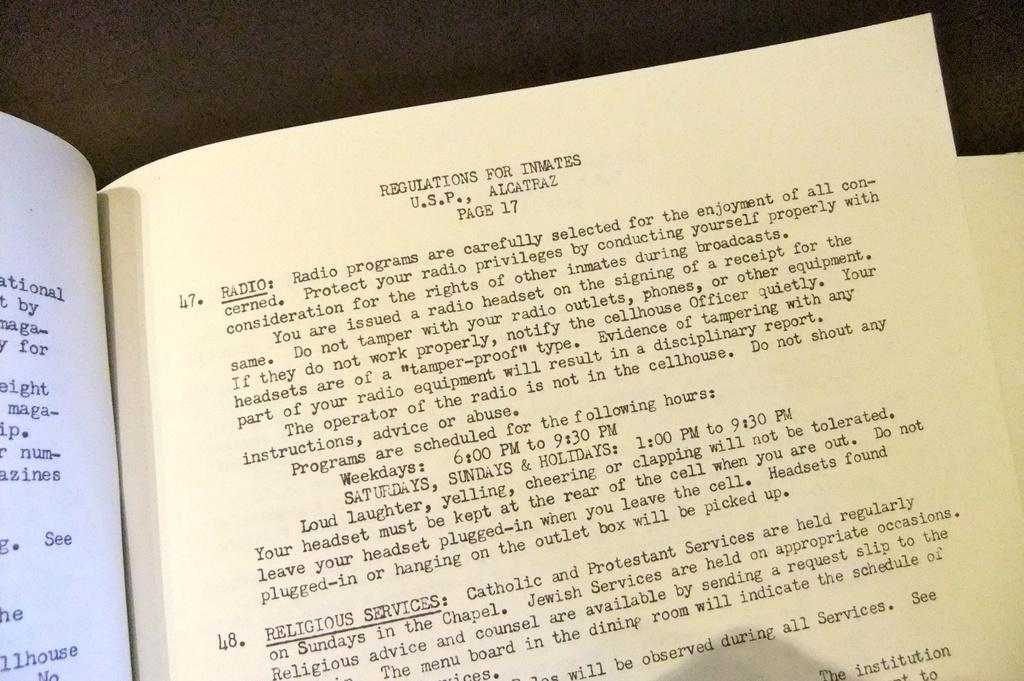What is depicted in the image? There are pages of a book in the image. What can be found on the pages of the book? The pages have matter printed on them. Can you see a deer on the pages of the book in the image? There is no deer present on the pages of the book in the image. How does the wave of the ocean affect the pages of the book in the image? There is no wave or ocean present in the image; it only features pages of a book with printed matter. 